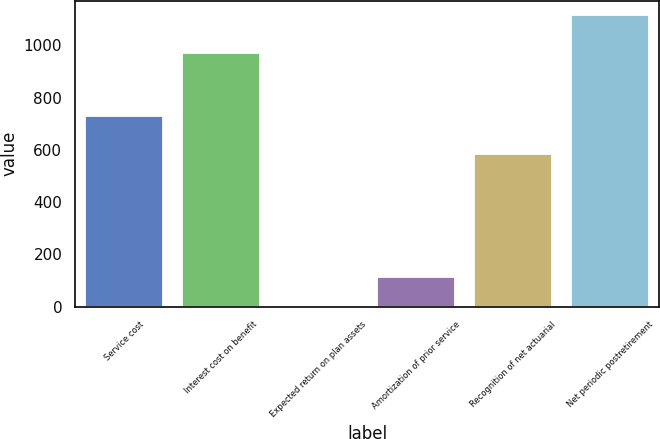<chart> <loc_0><loc_0><loc_500><loc_500><bar_chart><fcel>Service cost<fcel>Interest cost on benefit<fcel>Expected return on plan assets<fcel>Amortization of prior service<fcel>Recognition of net actuarial<fcel>Net periodic postretirement<nl><fcel>728<fcel>970<fcel>3.67<fcel>114.8<fcel>583<fcel>1115<nl></chart> 